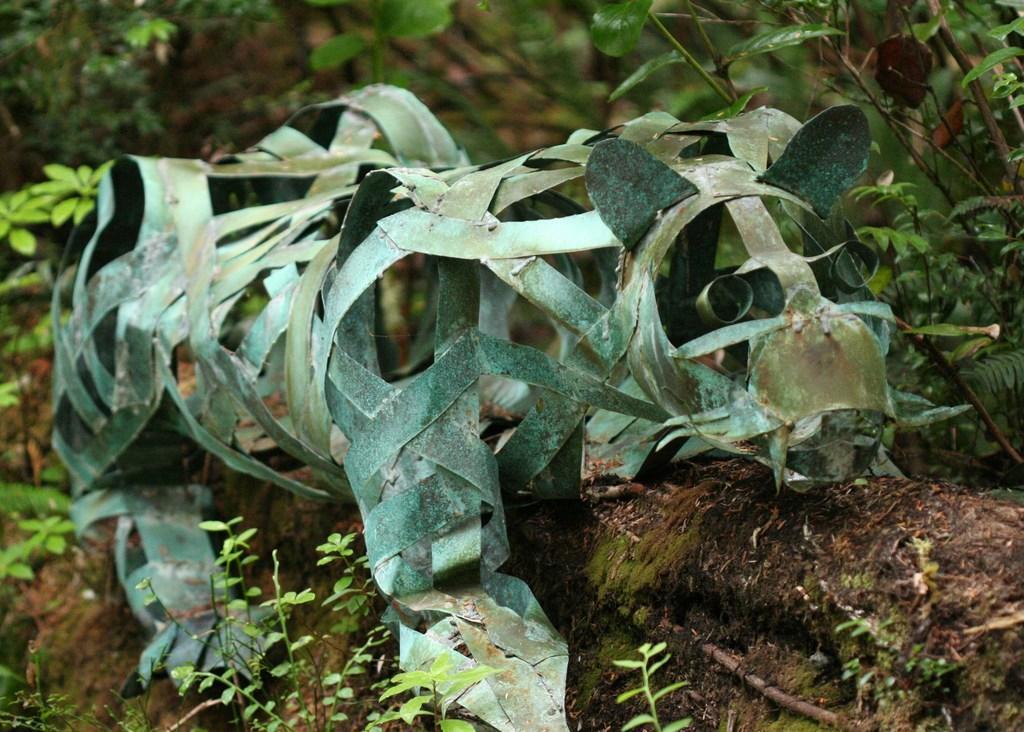Describe this image in one or two sentences. In this image there is a reptile sculpture made from coconut tree leaves, behind the sculpture there are plants. 